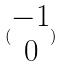Convert formula to latex. <formula><loc_0><loc_0><loc_500><loc_500>( \begin{matrix} - 1 \\ 0 \end{matrix} )</formula> 